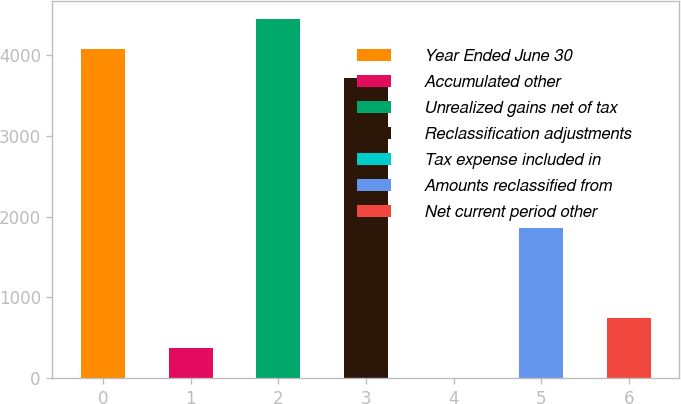Convert chart. <chart><loc_0><loc_0><loc_500><loc_500><bar_chart><fcel>Year Ended June 30<fcel>Accumulated other<fcel>Unrealized gains net of tax<fcel>Reclassification adjustments<fcel>Tax expense included in<fcel>Amounts reclassified from<fcel>Net current period other<nl><fcel>4078.2<fcel>376.2<fcel>4448.4<fcel>3708<fcel>6<fcel>1857<fcel>746.4<nl></chart> 